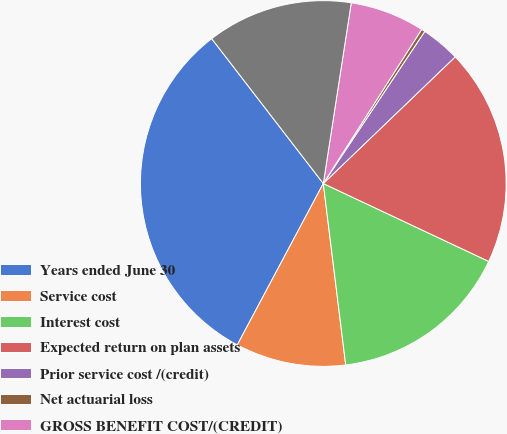Convert chart to OTSL. <chart><loc_0><loc_0><loc_500><loc_500><pie_chart><fcel>Years ended June 30<fcel>Service cost<fcel>Interest cost<fcel>Expected return on plan assets<fcel>Prior service cost /(credit)<fcel>Net actuarial loss<fcel>GROSS BENEFIT COST/(CREDIT)<fcel>NET PERIODIC BENEFIT<nl><fcel>31.76%<fcel>9.75%<fcel>16.04%<fcel>19.18%<fcel>3.46%<fcel>0.32%<fcel>6.6%<fcel>12.89%<nl></chart> 